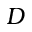<formula> <loc_0><loc_0><loc_500><loc_500>D</formula> 